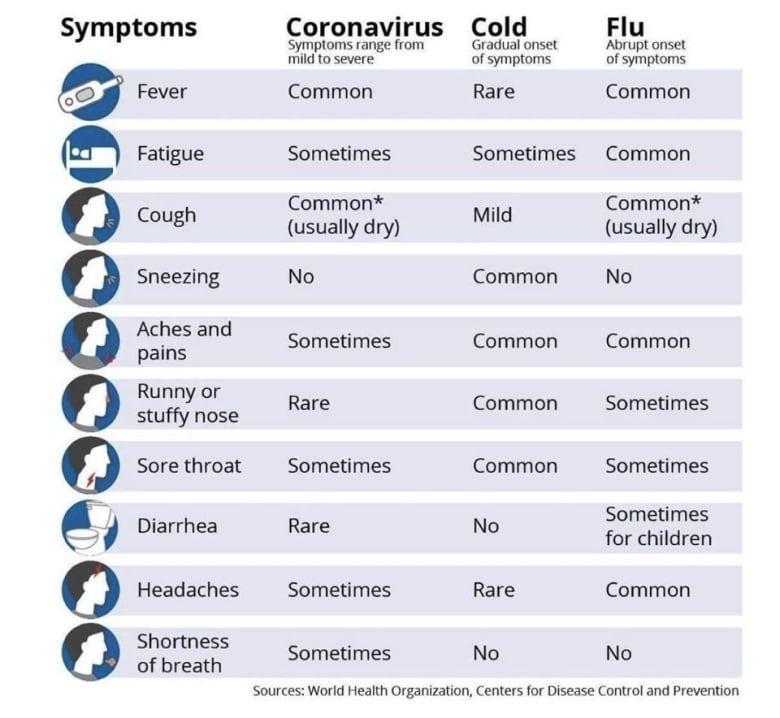Which is never a symptom of both cold & Flu?
Answer the question with a short phrase. Shortness of breath Which are the rare symptoms of coronavirus? Runny or stuffy nose, Diarrhea Which is never a symptom of both Coronavirus & Flu? Sneezing Which symptom does occur sometimes for both Coronavirus & cold? Fatigue What are the common symptoms of both Coronavirus & Flu? Fever, Cough Which are the rare symptoms of cold? Fever, Headaches 